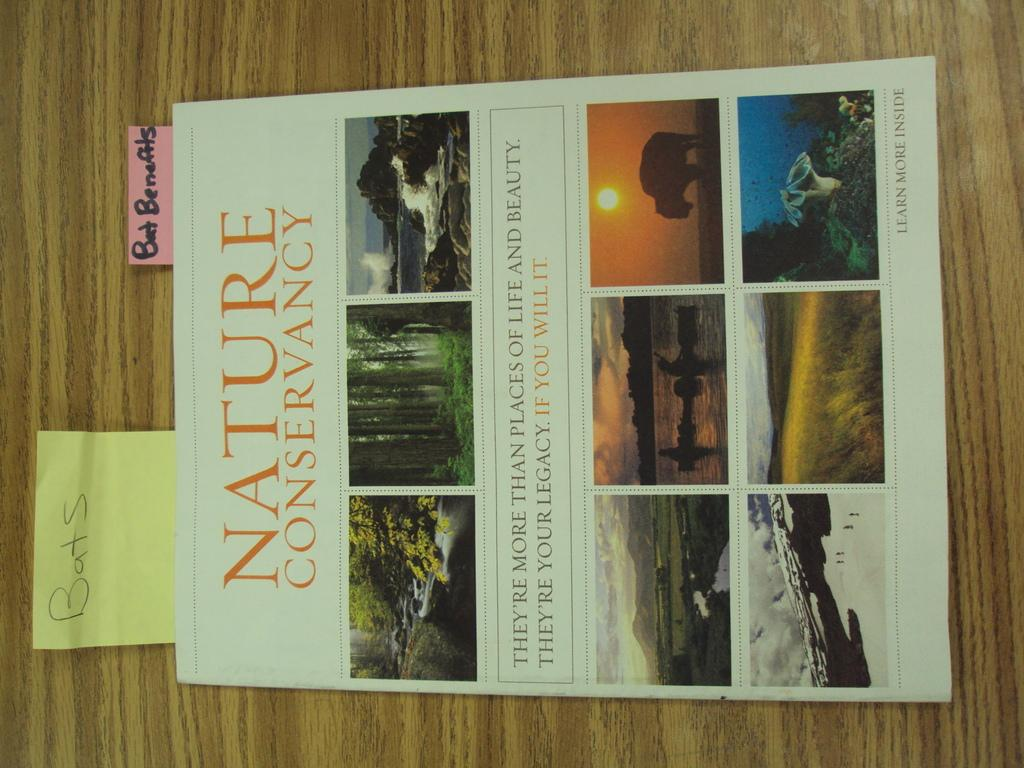<image>
Create a compact narrative representing the image presented. a magazine that is called nature conservancy and says learn more inside 